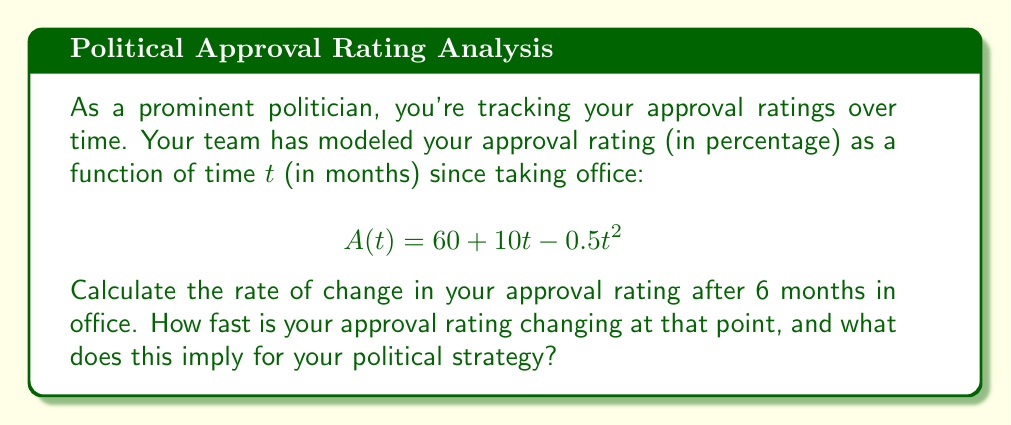Teach me how to tackle this problem. To solve this problem, we need to follow these steps:

1) The rate of change of the approval rating is given by the derivative of the function $A(t)$ with respect to $t$.

2) Let's find the derivative $A'(t)$:
   $$A'(t) = \frac{d}{dt}(60 + 10t - 0.5t^2)$$
   $$A'(t) = 0 + 10 - 1t$$
   $$A'(t) = 10 - t$$

3) Now, we need to evaluate this at $t = 6$ months:
   $$A'(6) = 10 - 6 = 4$$

4) Interpret the result:
   The rate of change after 6 months is 4 percentage points per month.
   This is positive, meaning the approval rating is still increasing, but slower than initially.

5) Political strategy implication:
   While still gaining approval, the rate is slowing. This suggests a need to reinforce positive messaging and potentially introduce new initiatives to maintain momentum.
Answer: $4$ percentage points per month 